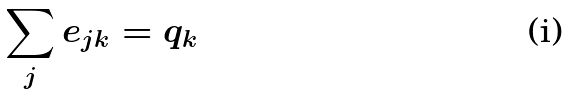Convert formula to latex. <formula><loc_0><loc_0><loc_500><loc_500>\sum _ { j } e _ { j k } = q _ { k }</formula> 